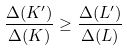<formula> <loc_0><loc_0><loc_500><loc_500>\frac { \Delta ( K ^ { \prime } ) } { \Delta ( K ) } \geq \frac { \Delta ( L ^ { \prime } ) } { \Delta ( L ) }</formula> 